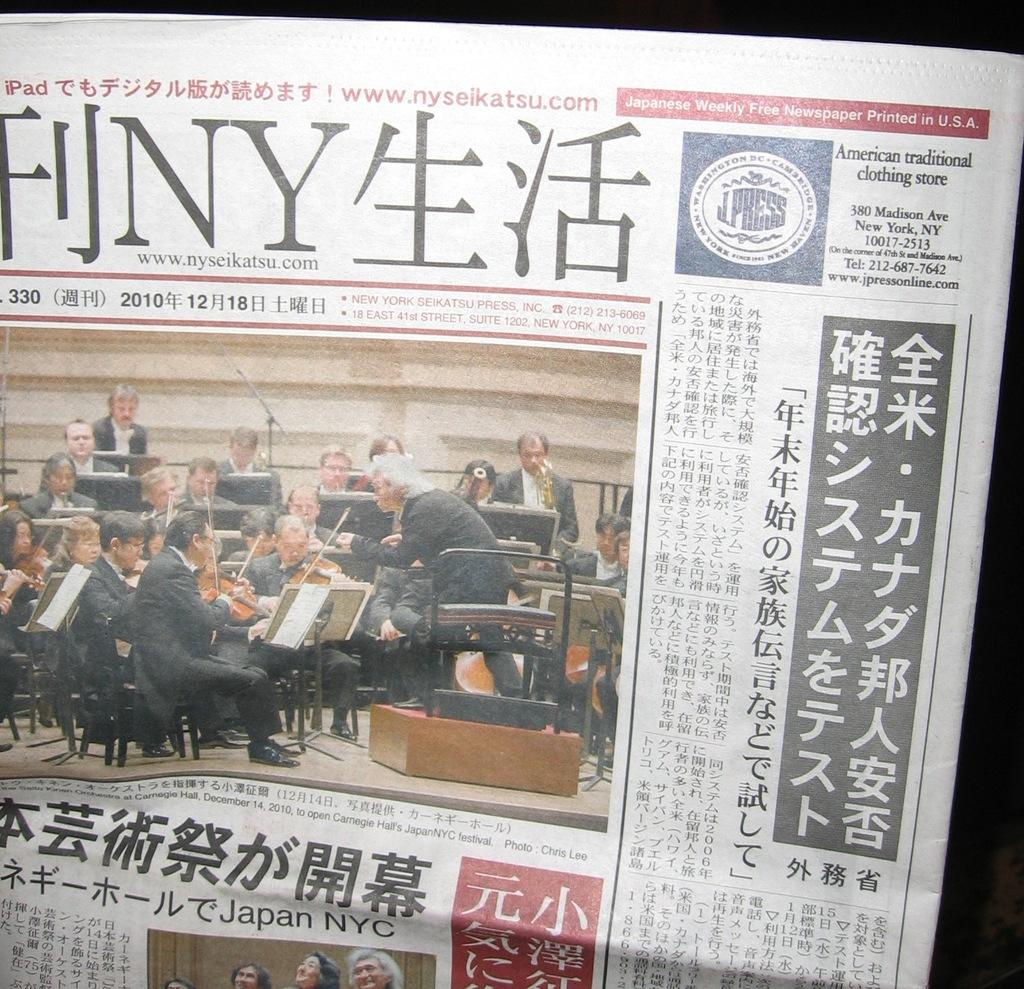<image>
Render a clear and concise summary of the photo. Japanese Free Newspaper is printed on the upper right corner of the newspaper. 